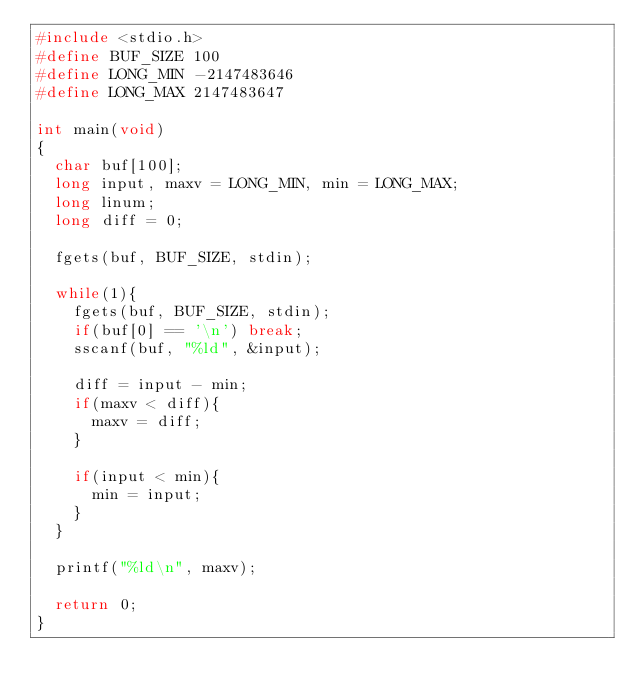<code> <loc_0><loc_0><loc_500><loc_500><_C_>#include <stdio.h>
#define BUF_SIZE 100
#define LONG_MIN -2147483646
#define LONG_MAX 2147483647

int main(void)
{
  char buf[100];
  long input, maxv = LONG_MIN, min = LONG_MAX;
  long linum;
  long diff = 0;

  fgets(buf, BUF_SIZE, stdin);

  while(1){
    fgets(buf, BUF_SIZE, stdin);
    if(buf[0] == '\n') break;
    sscanf(buf, "%ld", &input);

    diff = input - min;
    if(maxv < diff){
      maxv = diff;
    }

    if(input < min){
      min = input;
    }
  }

  printf("%ld\n", maxv);

  return 0;
}</code> 